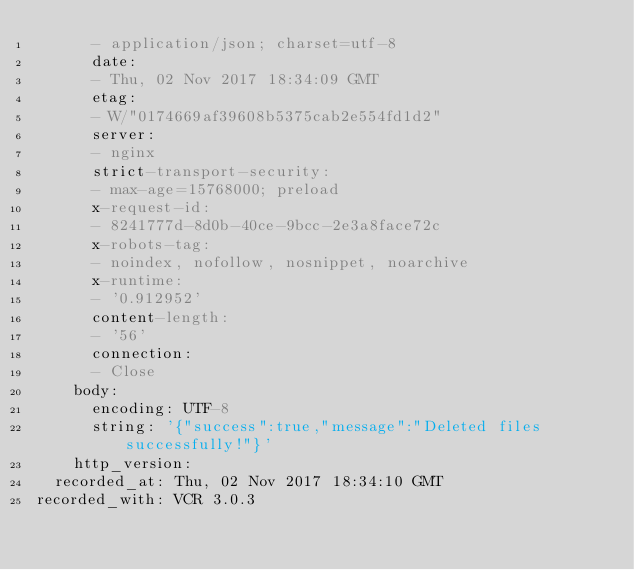<code> <loc_0><loc_0><loc_500><loc_500><_YAML_>      - application/json; charset=utf-8
      date:
      - Thu, 02 Nov 2017 18:34:09 GMT
      etag:
      - W/"0174669af39608b5375cab2e554fd1d2"
      server:
      - nginx
      strict-transport-security:
      - max-age=15768000; preload
      x-request-id:
      - 8241777d-8d0b-40ce-9bcc-2e3a8face72c
      x-robots-tag:
      - noindex, nofollow, nosnippet, noarchive
      x-runtime:
      - '0.912952'
      content-length:
      - '56'
      connection:
      - Close
    body:
      encoding: UTF-8
      string: '{"success":true,"message":"Deleted files successfully!"}'
    http_version:
  recorded_at: Thu, 02 Nov 2017 18:34:10 GMT
recorded_with: VCR 3.0.3
</code> 